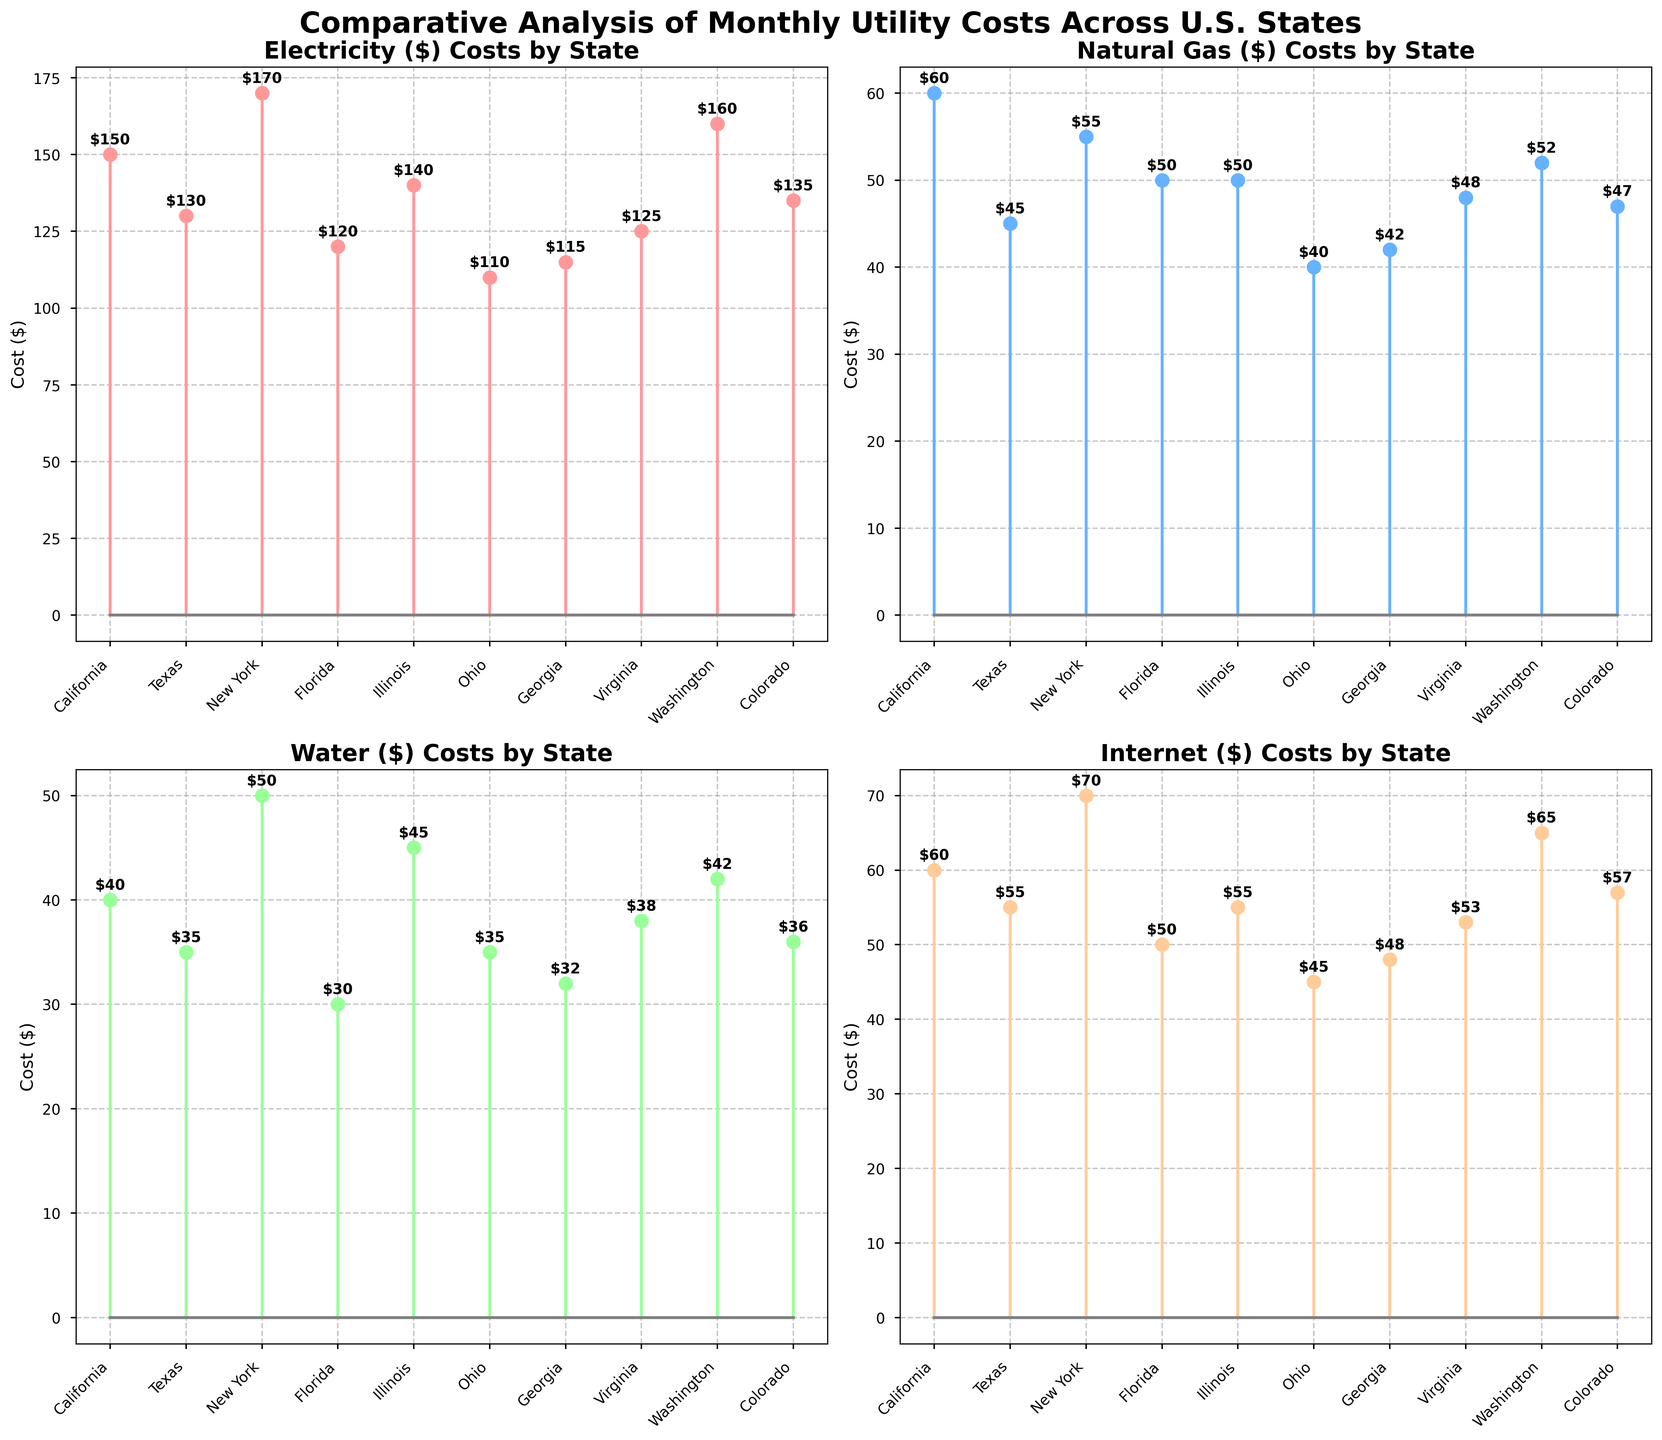What is the cost of electricity in New York? Look at the electricity plot, find the bar corresponding to New York, then read the value.
Answer: $170 Which state has the highest internet cost? Identify the state with the highest point in the internet plot. The peak value in the internet plot is for New York.
Answer: New York What is the difference in water costs between California and Texas? Locate the water cost points for both California and Texas, and subtract the lower cost from the higher cost: 40 (California) - 35 (Texas) = 5.
Answer: $5 Which state has the lowest natural gas cost? Find the state with the lowest point in the natural gas plot. The lowest point is for Ohio.
Answer: Ohio What's the average internet cost across all states? Add all the internet costs: 60 + 55 + 70 + 50 + 55 + 45 + 48 + 53 + 65 + 57. Then divide by the number of states (10). The sum is 558, average is 558 / 10 = 55.8
Answer: $55.8 Compare the electricity costs of California and Ohio. Which one is higher? Locate the points for electricity costs for California and Ohio: California is $150, Ohio is $110. California has a higher cost.
Answer: California What is the combined total cost of electricity and water in Florida? Sum the electricity and water costs for Florida: 120 (Electricity) + 30 (Water) = 150.
Answer: $150 What state has the lowest overall utility cost (sum of electricity, natural gas, water, and internet)? Calculate the total utility cost for each state by summing all the individual costs. For brevity: California (150+60+40+60=310), Texas (130+45+35+55=265), New York (170+55+50+70=345), Florida (120+50+30+50=250), Illinois (140+50+45+55=290), Ohio (110+40+35+45=230), Georgia (115+42+32+48=237), Virginia (125+48+38+53=264), Washington (160+52+42+65=319), Colorado (135+47+36+57= 275). The lowest overall cost is for Ohio.
Answer: Ohio How many states have electricity costs over $150? Count the number of states with electricity costs above $150 by looking at the electricity plot: California ($150), New York ($170), and Washington ($160).
Answer: 3 Which state has the highest variability in costs across the different utilities? Determine the range for each state by identifying the maximum and minimum costs across the utilities, then calculate the difference. For brevity: California has (170-40=130), Texas (130-35=95), New York (170-50=120), Florida (120-30=90), Illinois (140-45=95), Ohio (110-35=75), Georgia (115-32=83), Virginia (125-38=87), Washington (160-42=118), Colorado (135-36=99). California has the highest variability in costs.
Answer: California 